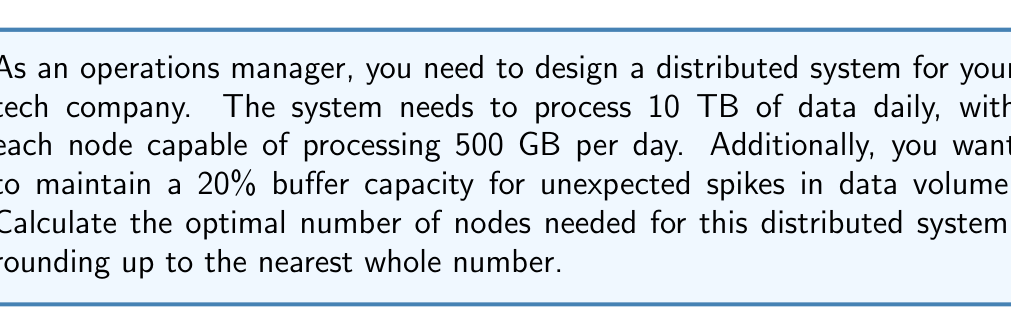What is the answer to this math problem? To calculate the optimal number of nodes, we need to follow these steps:

1. Calculate the total data processing requirement, including the buffer:
   Daily data volume = 10 TB
   Buffer = 20% = 0.2
   Total processing requirement = $10 \text{ TB} \times (1 + 0.2) = 12 \text{ TB}$

2. Convert the total processing requirement to GB:
   $12 \text{ TB} = 12,000 \text{ GB}$

3. Calculate the number of nodes needed:
   Processing capacity per node = 500 GB/day
   Number of nodes = $\frac{\text{Total processing requirement}}{\text{Processing capacity per node}}$
   
   $\text{Number of nodes} = \frac{12,000 \text{ GB}}{500 \text{ GB/day}} = 24$

4. Round up to the nearest whole number:
   Since we can't have a fractional number of nodes, we round up to ensure we meet the processing requirements.

   Optimal number of nodes = $\lceil 24 \rceil = 24$

Therefore, the optimal number of nodes for the distributed system is 24.
Answer: 24 nodes 